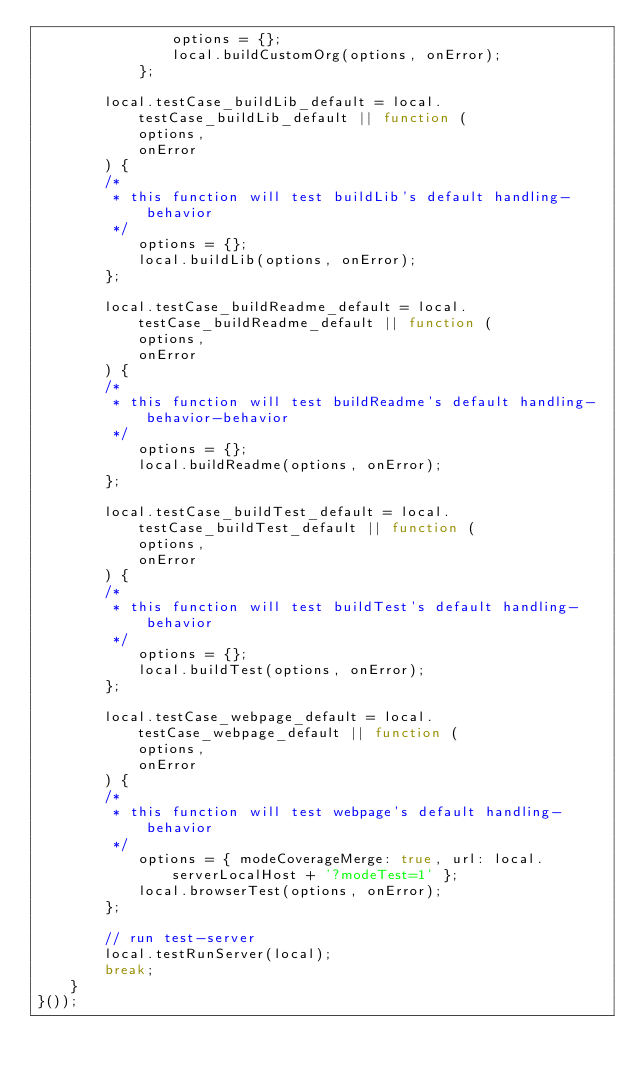Convert code to text. <code><loc_0><loc_0><loc_500><loc_500><_JavaScript_>                options = {};
                local.buildCustomOrg(options, onError);
            };

        local.testCase_buildLib_default = local.testCase_buildLib_default || function (
            options,
            onError
        ) {
        /*
         * this function will test buildLib's default handling-behavior
         */
            options = {};
            local.buildLib(options, onError);
        };

        local.testCase_buildReadme_default = local.testCase_buildReadme_default || function (
            options,
            onError
        ) {
        /*
         * this function will test buildReadme's default handling-behavior-behavior
         */
            options = {};
            local.buildReadme(options, onError);
        };

        local.testCase_buildTest_default = local.testCase_buildTest_default || function (
            options,
            onError
        ) {
        /*
         * this function will test buildTest's default handling-behavior
         */
            options = {};
            local.buildTest(options, onError);
        };

        local.testCase_webpage_default = local.testCase_webpage_default || function (
            options,
            onError
        ) {
        /*
         * this function will test webpage's default handling-behavior
         */
            options = { modeCoverageMerge: true, url: local.serverLocalHost + '?modeTest=1' };
            local.browserTest(options, onError);
        };

        // run test-server
        local.testRunServer(local);
        break;
    }
}());
</code> 